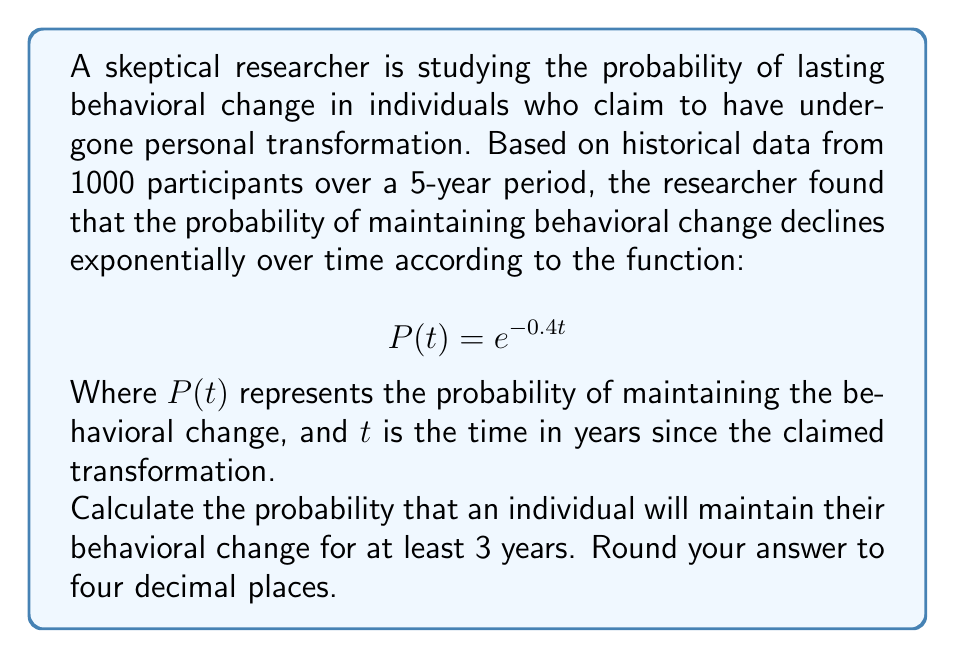Can you solve this math problem? To solve this problem, we need to use the given probability function and determine the probability at $t = 3$ years. This will give us the probability of maintaining the behavioral change for at least 3 years.

Step 1: Substitute $t = 3$ into the given function.
$$P(3) = e^{-0.4(3)}$$

Step 2: Simplify the exponent.
$$P(3) = e^{-1.2}$$

Step 3: Calculate the value of $e^{-1.2}$ using a calculator or mathematical software.
$$P(3) \approx 0.30119421191220214$$

Step 4: Round the result to four decimal places.
$$P(3) \approx 0.3012$$

Therefore, the probability that an individual will maintain their behavioral change for at least 3 years is approximately 0.3012 or 30.12%.
Answer: 0.3012 